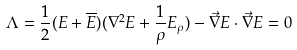Convert formula to latex. <formula><loc_0><loc_0><loc_500><loc_500>\Lambda = \frac { 1 } { 2 } ( E + \overline { E } ) ( \nabla ^ { 2 } E + \frac { 1 } { \rho } E _ { \rho } ) - \vec { \nabla } E \cdot \vec { \nabla } E = 0</formula> 